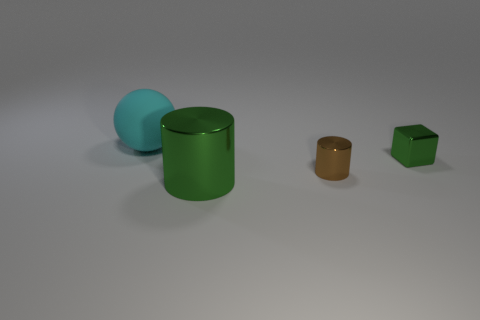Are there any other things that have the same material as the big cyan object?
Offer a very short reply. No. There is a object that is behind the shiny cube; what color is it?
Make the answer very short. Cyan. Is there anything else that is the same shape as the matte thing?
Make the answer very short. No. Is the number of big green shiny cylinders to the left of the sphere the same as the number of tiny gray balls?
Your response must be concise. Yes. How many small blocks have the same material as the large green cylinder?
Your response must be concise. 1. What color is the small thing that is made of the same material as the tiny green cube?
Your response must be concise. Brown. Do the small brown object and the large green object have the same shape?
Keep it short and to the point. Yes. Is there a tiny green metallic cube to the right of the green metallic thing that is left of the shiny cylinder on the right side of the large shiny object?
Keep it short and to the point. Yes. How many big things have the same color as the tiny metallic cube?
Ensure brevity in your answer.  1. There is a green object that is the same size as the brown thing; what is its shape?
Offer a very short reply. Cube. 